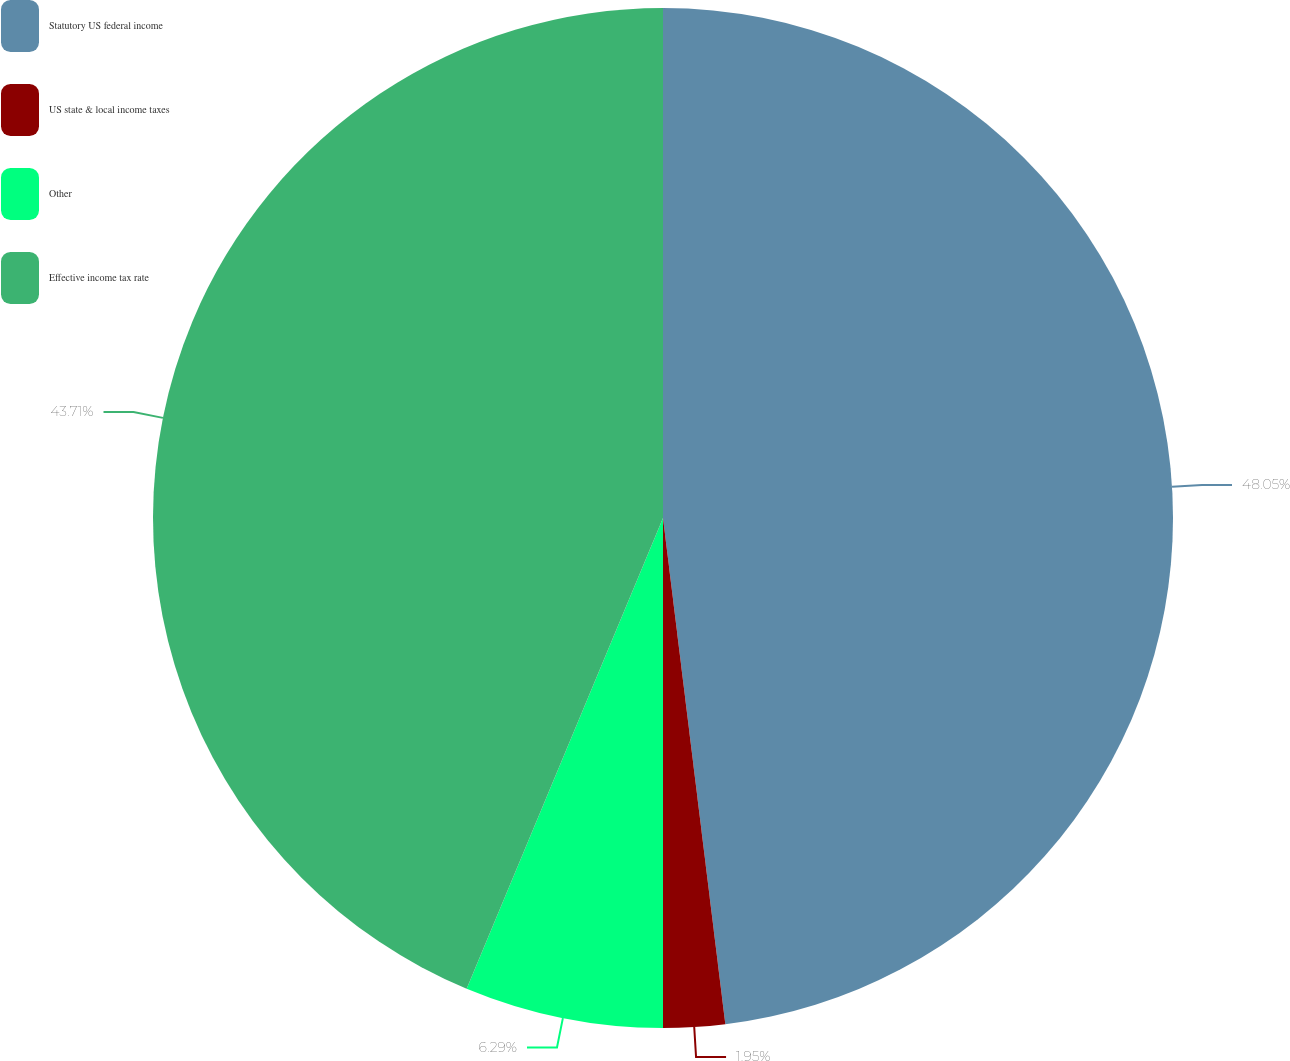Convert chart to OTSL. <chart><loc_0><loc_0><loc_500><loc_500><pie_chart><fcel>Statutory US federal income<fcel>US state & local income taxes<fcel>Other<fcel>Effective income tax rate<nl><fcel>48.05%<fcel>1.95%<fcel>6.29%<fcel>43.71%<nl></chart> 